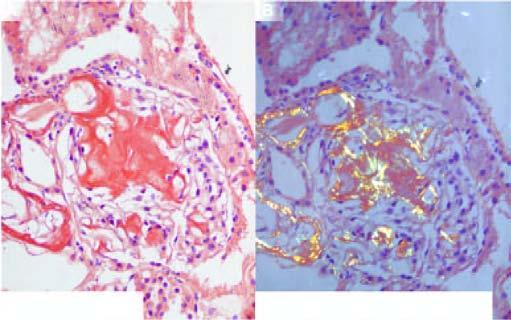do apoptosis show apple-green birefringence?
Answer the question using a single word or phrase. No 